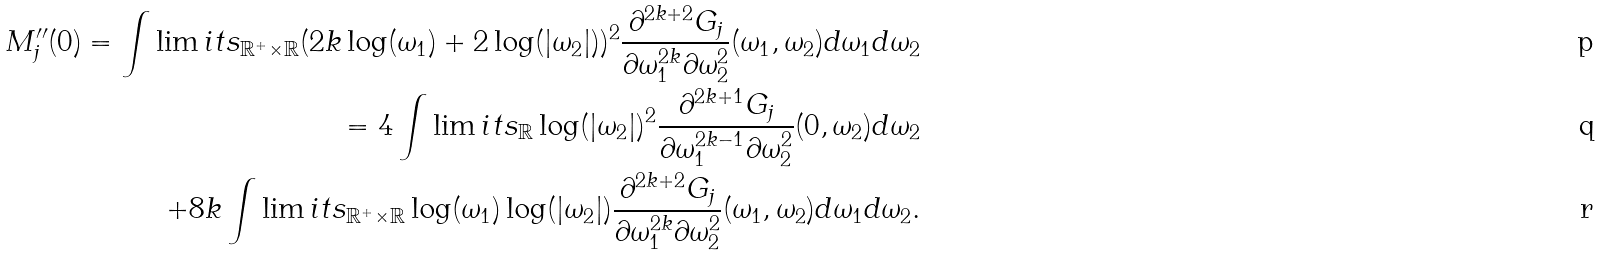Convert formula to latex. <formula><loc_0><loc_0><loc_500><loc_500>M _ { j } ^ { \prime \prime } ( 0 ) = \int \lim i t s _ { \mathbb { R } ^ { + } \times \mathbb { R } } ( 2 k \log ( \omega _ { 1 } ) + 2 \log ( | \omega _ { 2 } | ) ) ^ { 2 } \frac { \partial ^ { 2 k + 2 } G _ { j } } { \partial \omega _ { 1 } ^ { 2 k } \partial \omega _ { 2 } ^ { 2 } } ( \omega _ { 1 } , \omega _ { 2 } ) d \omega _ { 1 } d \omega _ { 2 } \\ = 4 \int \lim i t s _ { \mathbb { R } } \log ( | \omega _ { 2 } | ) ^ { 2 } \frac { \partial ^ { 2 k + 1 } G _ { j } } { \partial \omega _ { 1 } ^ { 2 k - 1 } \partial \omega _ { 2 } ^ { 2 } } ( 0 , \omega _ { 2 } ) d \omega _ { 2 } \\ + 8 k \int \lim i t s _ { \mathbb { R } ^ { + } \times \mathbb { R } } \log ( \omega _ { 1 } ) \log ( | \omega _ { 2 } | ) \frac { \partial ^ { 2 k + 2 } G _ { j } } { \partial \omega _ { 1 } ^ { 2 k } \partial \omega _ { 2 } ^ { 2 } } ( \omega _ { 1 } , \omega _ { 2 } ) d \omega _ { 1 } d \omega _ { 2 } .</formula> 